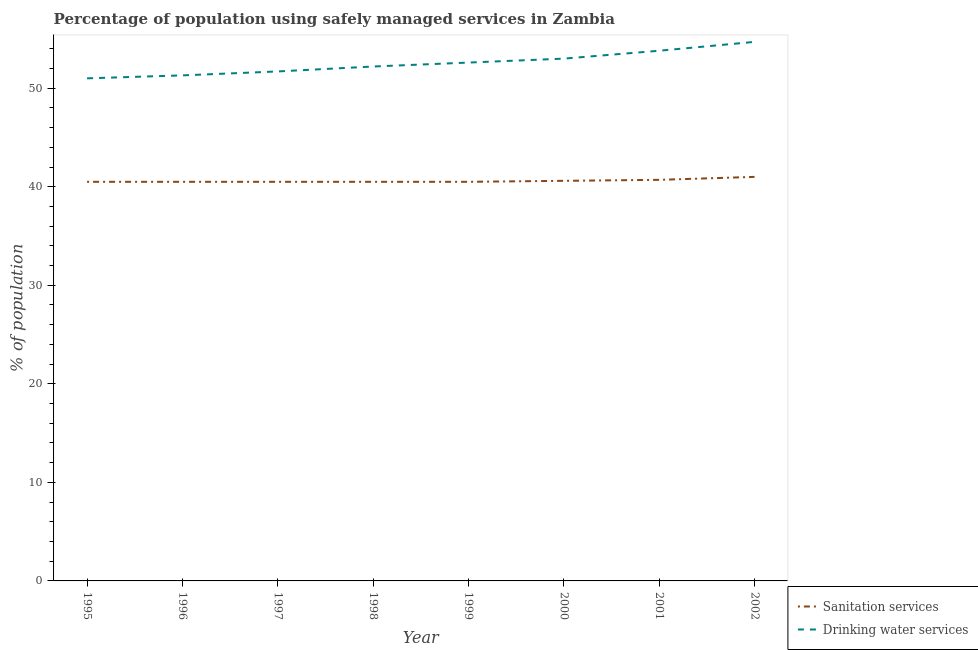How many different coloured lines are there?
Your answer should be compact. 2. Does the line corresponding to percentage of population who used sanitation services intersect with the line corresponding to percentage of population who used drinking water services?
Keep it short and to the point. No. What is the percentage of population who used drinking water services in 1995?
Offer a terse response. 51. Across all years, what is the minimum percentage of population who used sanitation services?
Provide a succinct answer. 40.5. In which year was the percentage of population who used sanitation services minimum?
Your answer should be compact. 1995. What is the total percentage of population who used drinking water services in the graph?
Offer a very short reply. 420.3. What is the difference between the percentage of population who used drinking water services in 1999 and that in 2000?
Your answer should be compact. -0.4. What is the difference between the percentage of population who used drinking water services in 1997 and the percentage of population who used sanitation services in 1995?
Keep it short and to the point. 11.2. What is the average percentage of population who used sanitation services per year?
Your response must be concise. 40.6. In the year 2001, what is the difference between the percentage of population who used drinking water services and percentage of population who used sanitation services?
Offer a terse response. 13.1. What is the ratio of the percentage of population who used drinking water services in 1996 to that in 2002?
Ensure brevity in your answer.  0.94. Is the percentage of population who used sanitation services in 1995 less than that in 1998?
Provide a short and direct response. No. What is the difference between the highest and the second highest percentage of population who used drinking water services?
Keep it short and to the point. 0.9. Is the sum of the percentage of population who used drinking water services in 1996 and 1997 greater than the maximum percentage of population who used sanitation services across all years?
Make the answer very short. Yes. How many years are there in the graph?
Your answer should be very brief. 8. What is the difference between two consecutive major ticks on the Y-axis?
Provide a succinct answer. 10. Are the values on the major ticks of Y-axis written in scientific E-notation?
Provide a short and direct response. No. How many legend labels are there?
Ensure brevity in your answer.  2. How are the legend labels stacked?
Give a very brief answer. Vertical. What is the title of the graph?
Provide a short and direct response. Percentage of population using safely managed services in Zambia. Does "Female population" appear as one of the legend labels in the graph?
Your answer should be compact. No. What is the label or title of the X-axis?
Your answer should be very brief. Year. What is the label or title of the Y-axis?
Your response must be concise. % of population. What is the % of population in Sanitation services in 1995?
Offer a very short reply. 40.5. What is the % of population of Sanitation services in 1996?
Provide a succinct answer. 40.5. What is the % of population of Drinking water services in 1996?
Your answer should be compact. 51.3. What is the % of population of Sanitation services in 1997?
Ensure brevity in your answer.  40.5. What is the % of population in Drinking water services in 1997?
Make the answer very short. 51.7. What is the % of population of Sanitation services in 1998?
Give a very brief answer. 40.5. What is the % of population in Drinking water services in 1998?
Offer a very short reply. 52.2. What is the % of population of Sanitation services in 1999?
Keep it short and to the point. 40.5. What is the % of population in Drinking water services in 1999?
Give a very brief answer. 52.6. What is the % of population in Sanitation services in 2000?
Ensure brevity in your answer.  40.6. What is the % of population in Sanitation services in 2001?
Give a very brief answer. 40.7. What is the % of population of Drinking water services in 2001?
Keep it short and to the point. 53.8. What is the % of population of Drinking water services in 2002?
Give a very brief answer. 54.7. Across all years, what is the maximum % of population in Sanitation services?
Your answer should be compact. 41. Across all years, what is the maximum % of population of Drinking water services?
Your response must be concise. 54.7. Across all years, what is the minimum % of population of Sanitation services?
Ensure brevity in your answer.  40.5. Across all years, what is the minimum % of population of Drinking water services?
Your response must be concise. 51. What is the total % of population of Sanitation services in the graph?
Provide a short and direct response. 324.8. What is the total % of population in Drinking water services in the graph?
Keep it short and to the point. 420.3. What is the difference between the % of population in Sanitation services in 1995 and that in 1996?
Provide a succinct answer. 0. What is the difference between the % of population in Drinking water services in 1995 and that in 1996?
Offer a terse response. -0.3. What is the difference between the % of population of Sanitation services in 1995 and that in 1997?
Your answer should be compact. 0. What is the difference between the % of population of Drinking water services in 1995 and that in 1997?
Give a very brief answer. -0.7. What is the difference between the % of population of Sanitation services in 1995 and that in 1999?
Your answer should be compact. 0. What is the difference between the % of population of Sanitation services in 1995 and that in 2001?
Your answer should be very brief. -0.2. What is the difference between the % of population of Drinking water services in 1995 and that in 2001?
Provide a short and direct response. -2.8. What is the difference between the % of population of Drinking water services in 1995 and that in 2002?
Provide a short and direct response. -3.7. What is the difference between the % of population in Sanitation services in 1996 and that in 1997?
Your answer should be very brief. 0. What is the difference between the % of population in Drinking water services in 1996 and that in 1997?
Make the answer very short. -0.4. What is the difference between the % of population in Sanitation services in 1996 and that in 1998?
Keep it short and to the point. 0. What is the difference between the % of population of Drinking water services in 1996 and that in 1998?
Make the answer very short. -0.9. What is the difference between the % of population in Sanitation services in 1996 and that in 1999?
Keep it short and to the point. 0. What is the difference between the % of population in Drinking water services in 1996 and that in 2000?
Your answer should be very brief. -1.7. What is the difference between the % of population in Drinking water services in 1996 and that in 2001?
Offer a terse response. -2.5. What is the difference between the % of population of Sanitation services in 1996 and that in 2002?
Offer a very short reply. -0.5. What is the difference between the % of population of Drinking water services in 1996 and that in 2002?
Keep it short and to the point. -3.4. What is the difference between the % of population in Sanitation services in 1997 and that in 1998?
Provide a short and direct response. 0. What is the difference between the % of population in Drinking water services in 1997 and that in 1999?
Ensure brevity in your answer.  -0.9. What is the difference between the % of population in Sanitation services in 1997 and that in 2000?
Ensure brevity in your answer.  -0.1. What is the difference between the % of population of Drinking water services in 1997 and that in 2000?
Provide a succinct answer. -1.3. What is the difference between the % of population of Drinking water services in 1997 and that in 2002?
Your answer should be compact. -3. What is the difference between the % of population in Sanitation services in 1998 and that in 1999?
Ensure brevity in your answer.  0. What is the difference between the % of population of Sanitation services in 1998 and that in 2000?
Provide a succinct answer. -0.1. What is the difference between the % of population of Drinking water services in 1998 and that in 2001?
Your answer should be compact. -1.6. What is the difference between the % of population in Drinking water services in 1999 and that in 2000?
Ensure brevity in your answer.  -0.4. What is the difference between the % of population in Drinking water services in 1999 and that in 2001?
Your answer should be compact. -1.2. What is the difference between the % of population in Drinking water services in 1999 and that in 2002?
Make the answer very short. -2.1. What is the difference between the % of population in Drinking water services in 2000 and that in 2002?
Keep it short and to the point. -1.7. What is the difference between the % of population in Sanitation services in 2001 and that in 2002?
Your response must be concise. -0.3. What is the difference between the % of population in Sanitation services in 1995 and the % of population in Drinking water services in 1998?
Provide a succinct answer. -11.7. What is the difference between the % of population of Sanitation services in 1995 and the % of population of Drinking water services in 2000?
Your answer should be compact. -12.5. What is the difference between the % of population of Sanitation services in 1996 and the % of population of Drinking water services in 1998?
Keep it short and to the point. -11.7. What is the difference between the % of population of Sanitation services in 1996 and the % of population of Drinking water services in 1999?
Offer a very short reply. -12.1. What is the difference between the % of population in Sanitation services in 1996 and the % of population in Drinking water services in 2000?
Give a very brief answer. -12.5. What is the difference between the % of population in Sanitation services in 1997 and the % of population in Drinking water services in 1999?
Offer a terse response. -12.1. What is the difference between the % of population in Sanitation services in 1997 and the % of population in Drinking water services in 2000?
Offer a terse response. -12.5. What is the difference between the % of population of Sanitation services in 1997 and the % of population of Drinking water services in 2001?
Make the answer very short. -13.3. What is the difference between the % of population in Sanitation services in 1997 and the % of population in Drinking water services in 2002?
Provide a succinct answer. -14.2. What is the difference between the % of population of Sanitation services in 1998 and the % of population of Drinking water services in 1999?
Keep it short and to the point. -12.1. What is the difference between the % of population in Sanitation services in 1998 and the % of population in Drinking water services in 2002?
Give a very brief answer. -14.2. What is the difference between the % of population in Sanitation services in 1999 and the % of population in Drinking water services in 2000?
Your response must be concise. -12.5. What is the difference between the % of population of Sanitation services in 1999 and the % of population of Drinking water services in 2002?
Give a very brief answer. -14.2. What is the difference between the % of population of Sanitation services in 2000 and the % of population of Drinking water services in 2002?
Provide a succinct answer. -14.1. What is the average % of population in Sanitation services per year?
Your answer should be compact. 40.6. What is the average % of population in Drinking water services per year?
Offer a terse response. 52.54. In the year 1995, what is the difference between the % of population of Sanitation services and % of population of Drinking water services?
Provide a short and direct response. -10.5. In the year 1997, what is the difference between the % of population in Sanitation services and % of population in Drinking water services?
Your answer should be very brief. -11.2. In the year 1998, what is the difference between the % of population in Sanitation services and % of population in Drinking water services?
Provide a short and direct response. -11.7. In the year 1999, what is the difference between the % of population in Sanitation services and % of population in Drinking water services?
Offer a very short reply. -12.1. In the year 2002, what is the difference between the % of population in Sanitation services and % of population in Drinking water services?
Make the answer very short. -13.7. What is the ratio of the % of population of Sanitation services in 1995 to that in 1997?
Your answer should be very brief. 1. What is the ratio of the % of population of Drinking water services in 1995 to that in 1997?
Your response must be concise. 0.99. What is the ratio of the % of population in Sanitation services in 1995 to that in 1999?
Keep it short and to the point. 1. What is the ratio of the % of population in Drinking water services in 1995 to that in 1999?
Offer a very short reply. 0.97. What is the ratio of the % of population of Drinking water services in 1995 to that in 2000?
Provide a succinct answer. 0.96. What is the ratio of the % of population of Sanitation services in 1995 to that in 2001?
Offer a very short reply. 1. What is the ratio of the % of population in Drinking water services in 1995 to that in 2001?
Provide a succinct answer. 0.95. What is the ratio of the % of population in Drinking water services in 1995 to that in 2002?
Your answer should be compact. 0.93. What is the ratio of the % of population of Drinking water services in 1996 to that in 1997?
Provide a short and direct response. 0.99. What is the ratio of the % of population of Sanitation services in 1996 to that in 1998?
Provide a succinct answer. 1. What is the ratio of the % of population in Drinking water services in 1996 to that in 1998?
Provide a succinct answer. 0.98. What is the ratio of the % of population of Drinking water services in 1996 to that in 1999?
Offer a terse response. 0.98. What is the ratio of the % of population of Drinking water services in 1996 to that in 2000?
Offer a terse response. 0.97. What is the ratio of the % of population in Sanitation services in 1996 to that in 2001?
Keep it short and to the point. 1. What is the ratio of the % of population of Drinking water services in 1996 to that in 2001?
Keep it short and to the point. 0.95. What is the ratio of the % of population of Drinking water services in 1996 to that in 2002?
Offer a terse response. 0.94. What is the ratio of the % of population of Sanitation services in 1997 to that in 1999?
Your answer should be very brief. 1. What is the ratio of the % of population in Drinking water services in 1997 to that in 1999?
Your response must be concise. 0.98. What is the ratio of the % of population in Sanitation services in 1997 to that in 2000?
Provide a short and direct response. 1. What is the ratio of the % of population in Drinking water services in 1997 to that in 2000?
Make the answer very short. 0.98. What is the ratio of the % of population in Drinking water services in 1997 to that in 2002?
Offer a very short reply. 0.95. What is the ratio of the % of population of Drinking water services in 1998 to that in 1999?
Offer a very short reply. 0.99. What is the ratio of the % of population of Drinking water services in 1998 to that in 2000?
Provide a succinct answer. 0.98. What is the ratio of the % of population in Drinking water services in 1998 to that in 2001?
Provide a short and direct response. 0.97. What is the ratio of the % of population in Sanitation services in 1998 to that in 2002?
Offer a terse response. 0.99. What is the ratio of the % of population in Drinking water services in 1998 to that in 2002?
Make the answer very short. 0.95. What is the ratio of the % of population of Sanitation services in 1999 to that in 2000?
Keep it short and to the point. 1. What is the ratio of the % of population of Drinking water services in 1999 to that in 2001?
Your response must be concise. 0.98. What is the ratio of the % of population of Sanitation services in 1999 to that in 2002?
Give a very brief answer. 0.99. What is the ratio of the % of population in Drinking water services in 1999 to that in 2002?
Offer a terse response. 0.96. What is the ratio of the % of population in Sanitation services in 2000 to that in 2001?
Your answer should be very brief. 1. What is the ratio of the % of population in Drinking water services in 2000 to that in 2001?
Your answer should be compact. 0.99. What is the ratio of the % of population in Sanitation services in 2000 to that in 2002?
Provide a succinct answer. 0.99. What is the ratio of the % of population of Drinking water services in 2000 to that in 2002?
Make the answer very short. 0.97. What is the ratio of the % of population in Sanitation services in 2001 to that in 2002?
Provide a short and direct response. 0.99. What is the ratio of the % of population of Drinking water services in 2001 to that in 2002?
Offer a very short reply. 0.98. What is the difference between the highest and the second highest % of population in Sanitation services?
Provide a succinct answer. 0.3. What is the difference between the highest and the second highest % of population in Drinking water services?
Offer a very short reply. 0.9. What is the difference between the highest and the lowest % of population of Sanitation services?
Ensure brevity in your answer.  0.5. 